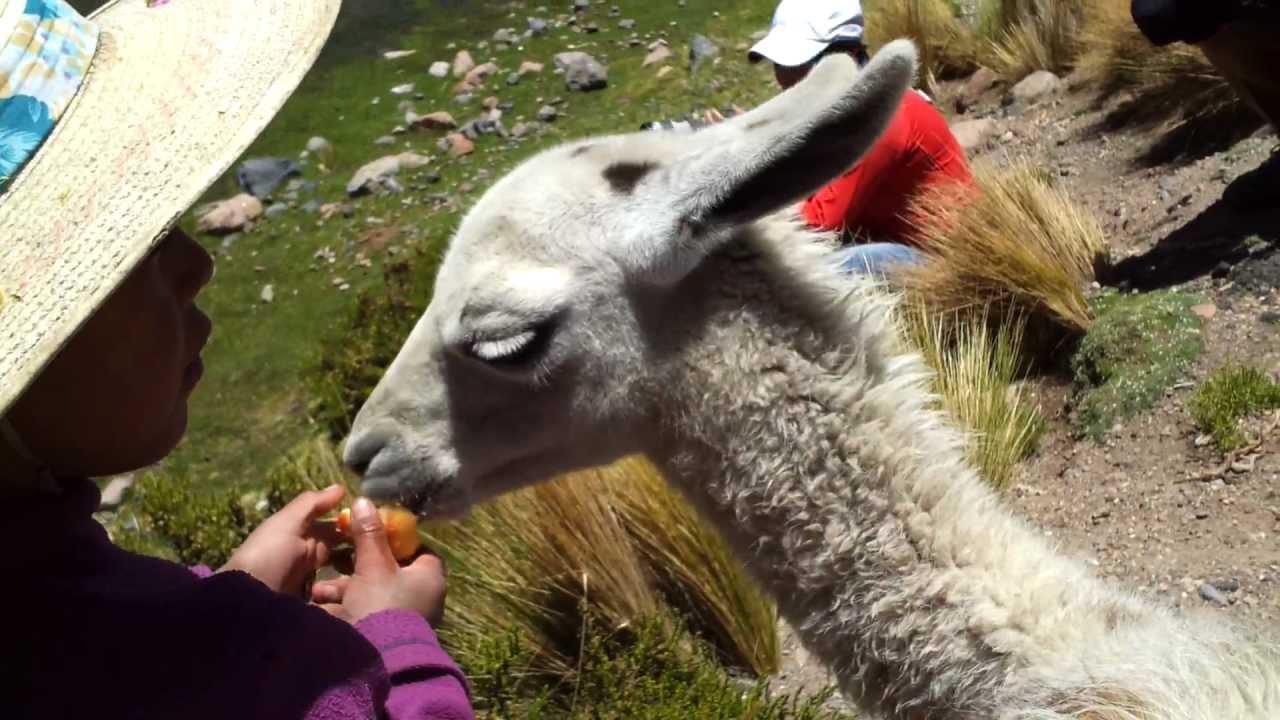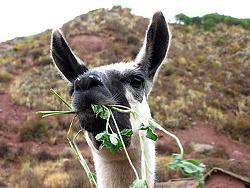The first image is the image on the left, the second image is the image on the right. Examine the images to the left and right. Is the description "A human is feeding one of the llamas" accurate? Answer yes or no. Yes. 